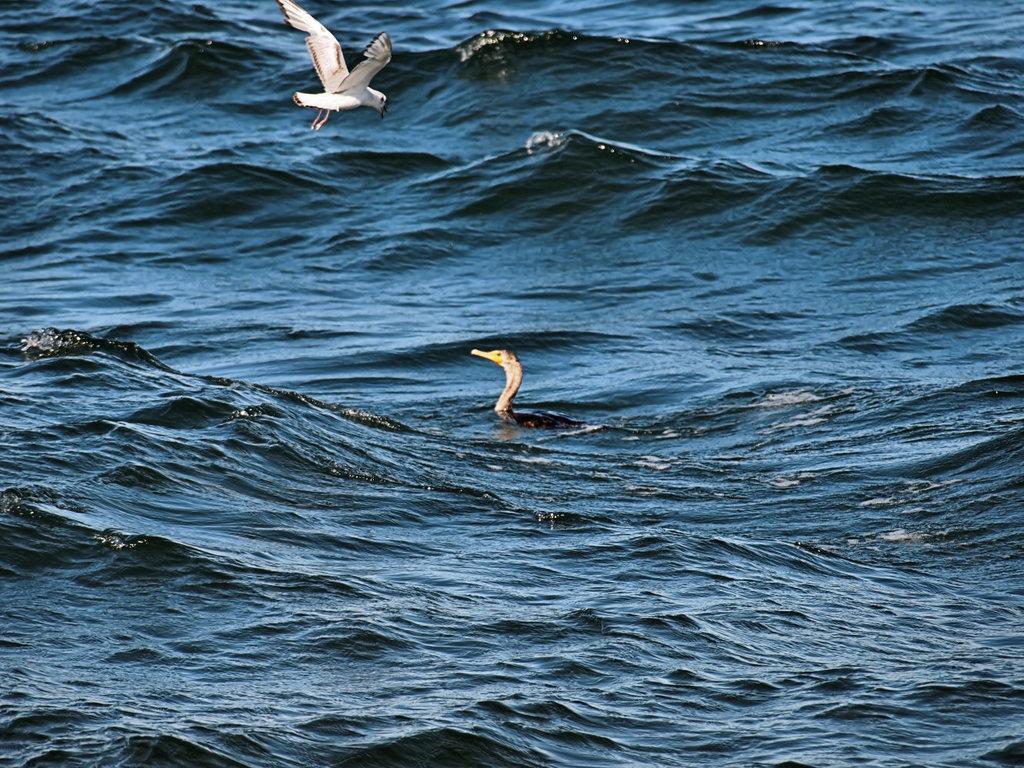How would you summarize this image in a sentence or two? In this image there is a duck in the water, there is a bird flying over the water. 